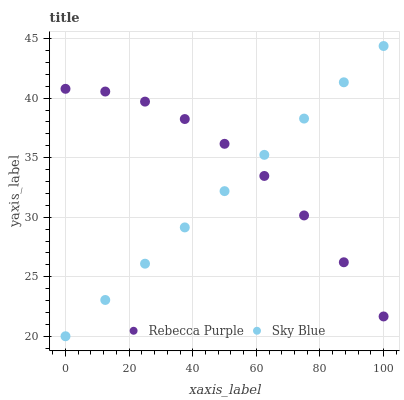Does Sky Blue have the minimum area under the curve?
Answer yes or no. Yes. Does Rebecca Purple have the maximum area under the curve?
Answer yes or no. Yes. Does Rebecca Purple have the minimum area under the curve?
Answer yes or no. No. Is Sky Blue the smoothest?
Answer yes or no. Yes. Is Rebecca Purple the roughest?
Answer yes or no. Yes. Is Rebecca Purple the smoothest?
Answer yes or no. No. Does Sky Blue have the lowest value?
Answer yes or no. Yes. Does Rebecca Purple have the lowest value?
Answer yes or no. No. Does Sky Blue have the highest value?
Answer yes or no. Yes. Does Rebecca Purple have the highest value?
Answer yes or no. No. Does Sky Blue intersect Rebecca Purple?
Answer yes or no. Yes. Is Sky Blue less than Rebecca Purple?
Answer yes or no. No. Is Sky Blue greater than Rebecca Purple?
Answer yes or no. No. 